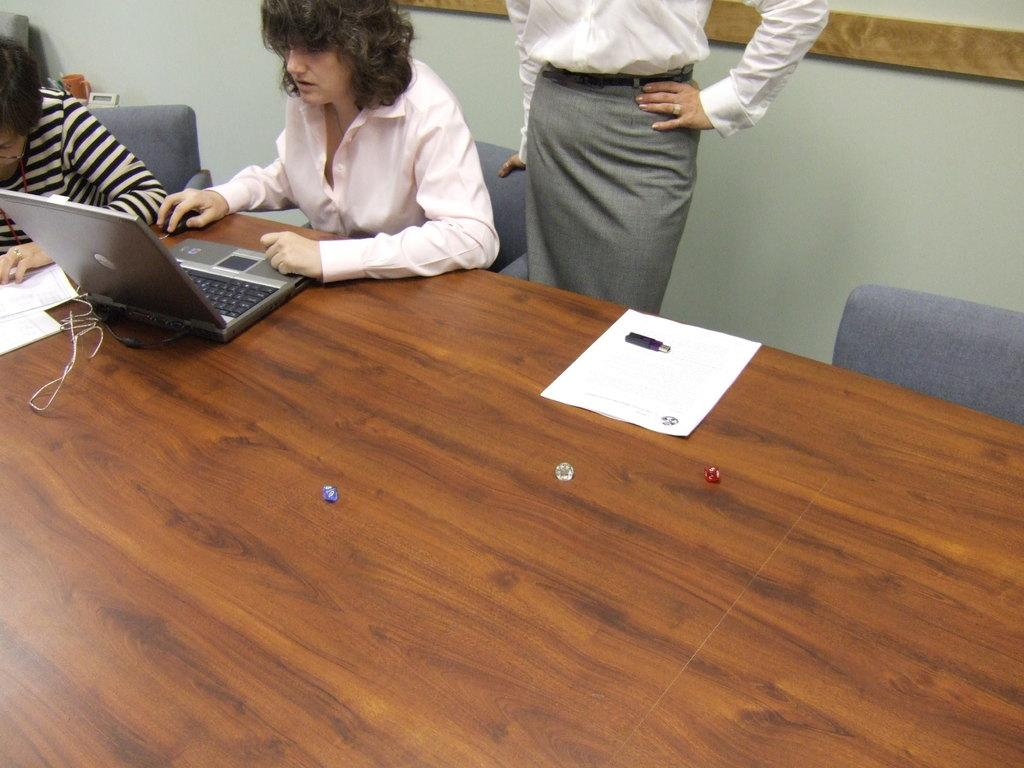How many women are in the image? There are three women in the image. What are the positions of the women in the image? Two of the women are sitting, and one of the women is standing. What is in front of the women? There is a table in front of the women. What can be seen on the table? A laptop is visible on the table. What is visible in the background of the image? There is a wall in the background of the image. What type of club can be seen in the hands of the standing woman in the image? There is no club visible in the hands of the standing woman in the image. What is the weather like in the image, considering the presence of fog? There is no mention of fog in the image; the background is a wall. 